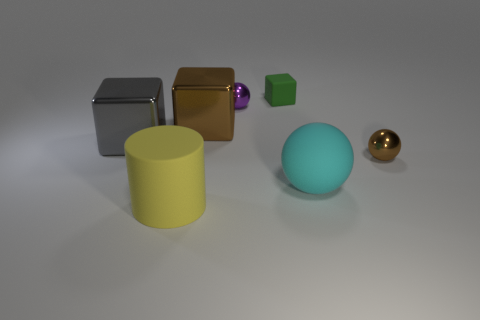What number of cyan objects have the same size as the yellow object?
Provide a succinct answer. 1. Is there a tiny brown shiny object?
Give a very brief answer. Yes. Is there anything else of the same color as the big cylinder?
Give a very brief answer. No. There is a tiny brown object that is made of the same material as the purple sphere; what is its shape?
Give a very brief answer. Sphere. What is the color of the small ball behind the large metal cube that is on the left side of the object that is in front of the large cyan rubber ball?
Your answer should be compact. Purple. Is the number of big gray objects that are in front of the small brown metallic object the same as the number of gray blocks?
Keep it short and to the point. No. Is there any other thing that is the same material as the large cylinder?
Your answer should be very brief. Yes. There is a matte cube; is its color the same as the large block left of the brown metallic cube?
Your answer should be very brief. No. Are there any metallic cubes that are on the right side of the brown shiny thing that is behind the small metallic sphere to the right of the big cyan matte thing?
Provide a short and direct response. No. Are there fewer big cubes that are behind the tiny purple metal ball than blue objects?
Offer a terse response. No. 